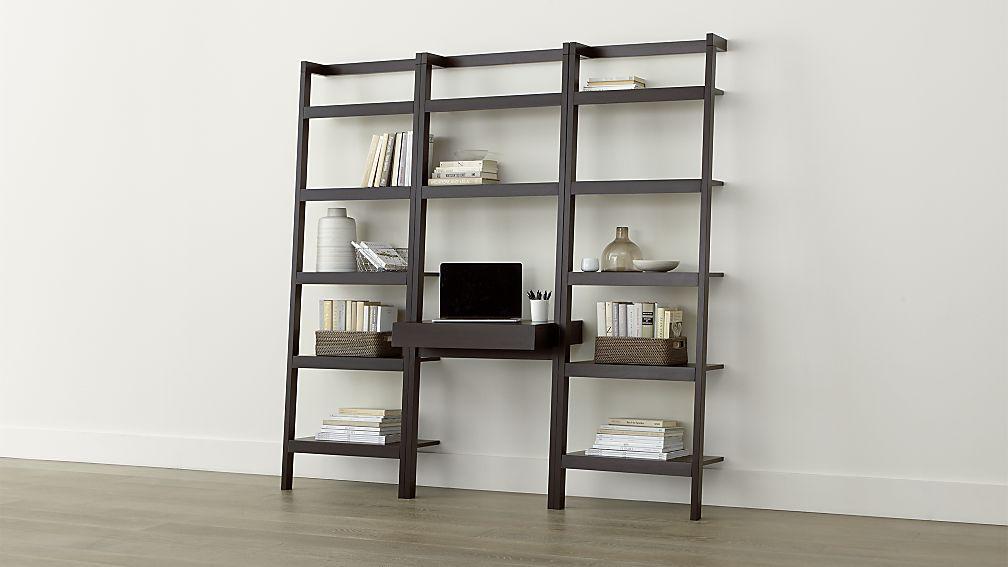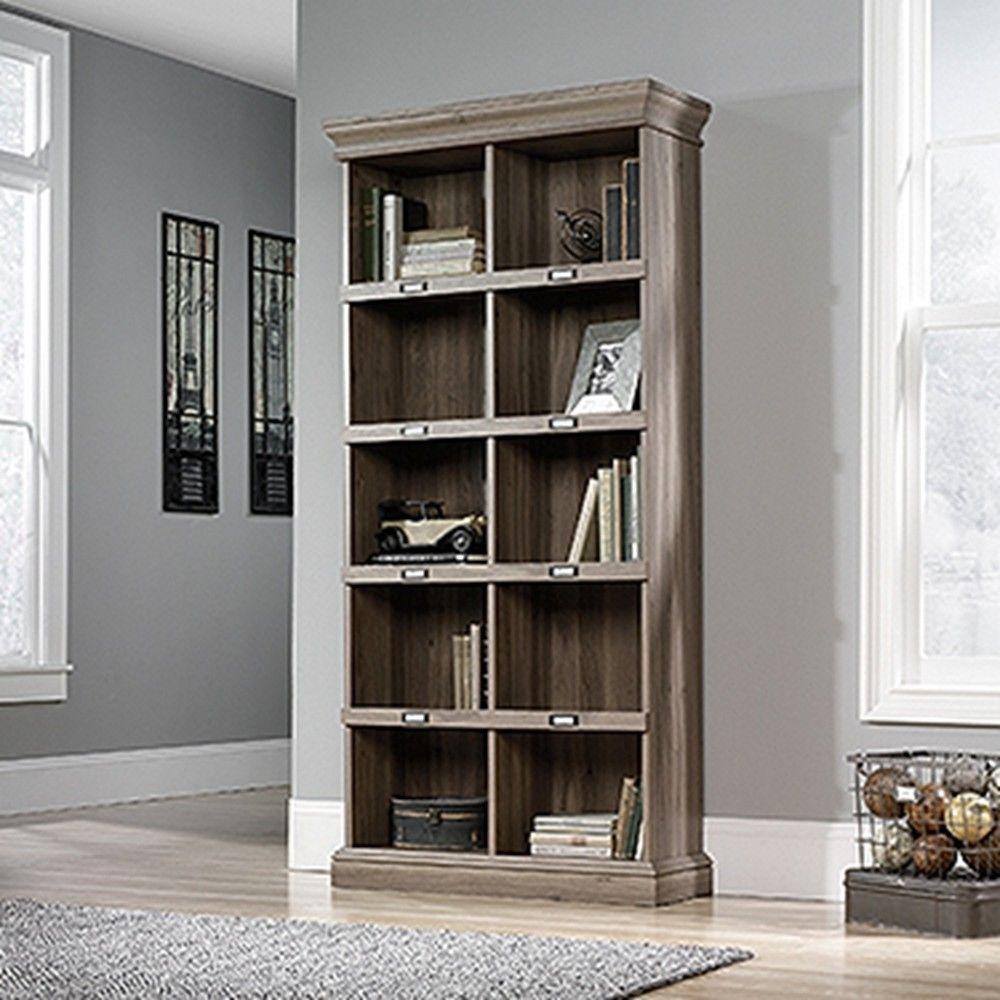The first image is the image on the left, the second image is the image on the right. Evaluate the accuracy of this statement regarding the images: "At least one bookcase has open shelves, no backboard to it.". Is it true? Answer yes or no. Yes. 